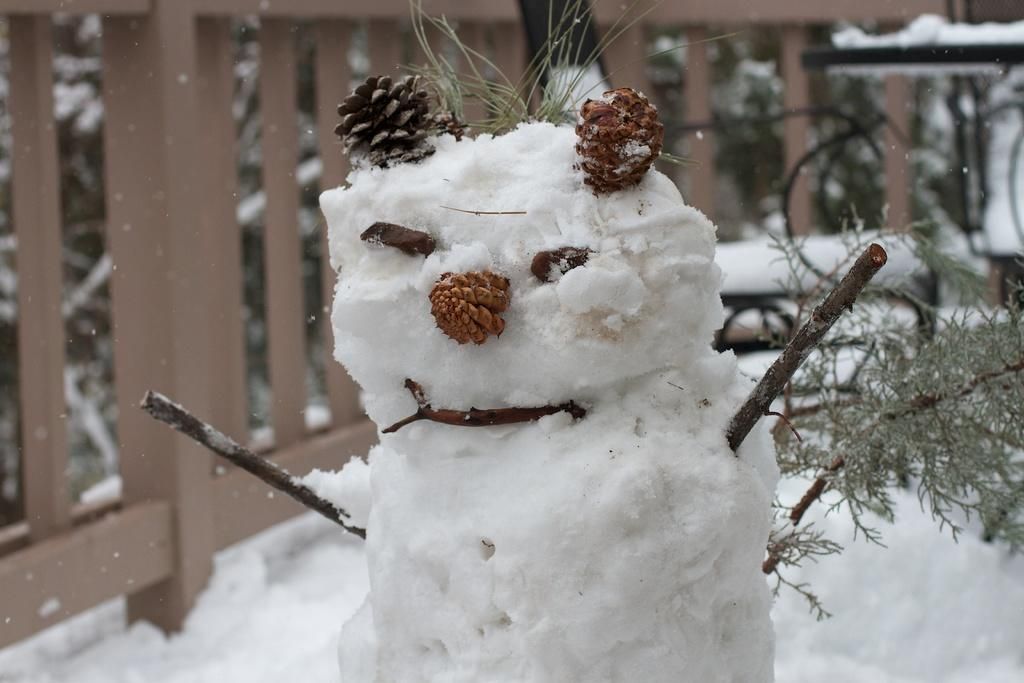What is the main subject of the image? There is a statue made with snow in the image. Where is the snow statue located? The statue is on a snow surface. What can be seen in the background of the image? There is a wooden fencing and plants in the background of the image. How is the snow present on the plants? Snow is present on the plants in the background. How many giraffes are visible in the image? There are no giraffes present in the image. What expertise does the person who made the snow statue have? The facts provided do not mention any person or their expertise in making the snow statue. 